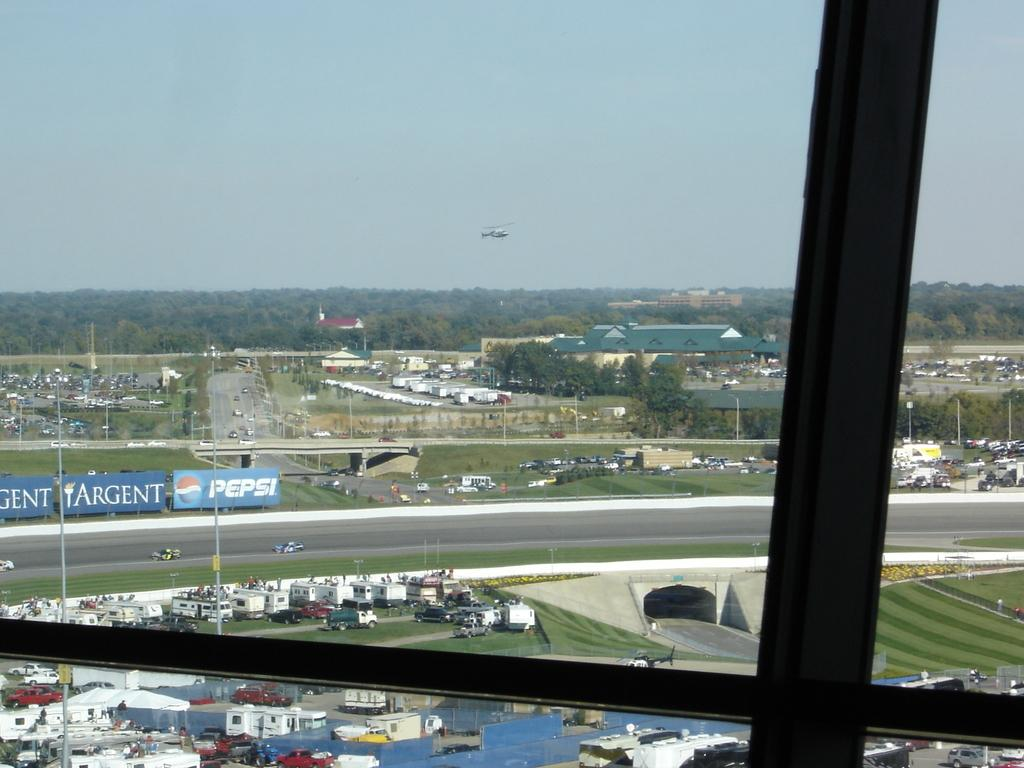<image>
Create a compact narrative representing the image presented. A pepsi banner and Argent banner both in blue outside. 